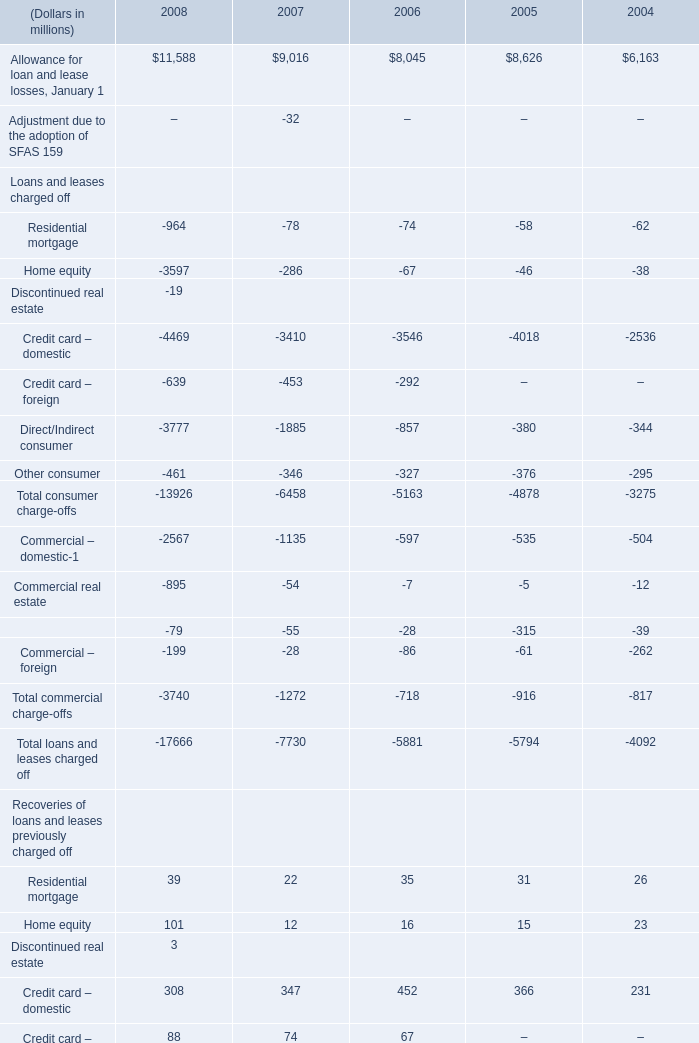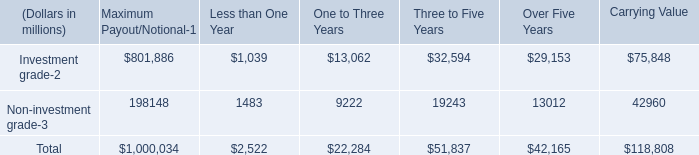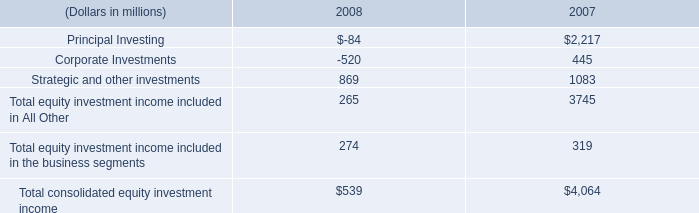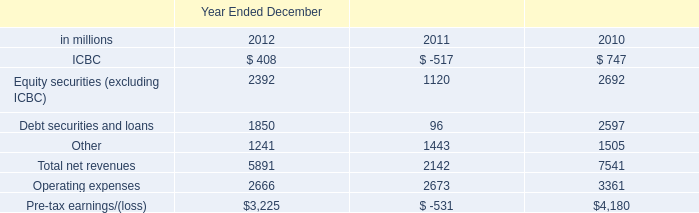What's the current increasing rate of Allowance for loan and lease losses, January 1? 
Computations: ((11588 - 9016) / 9016)
Answer: 0.28527. 